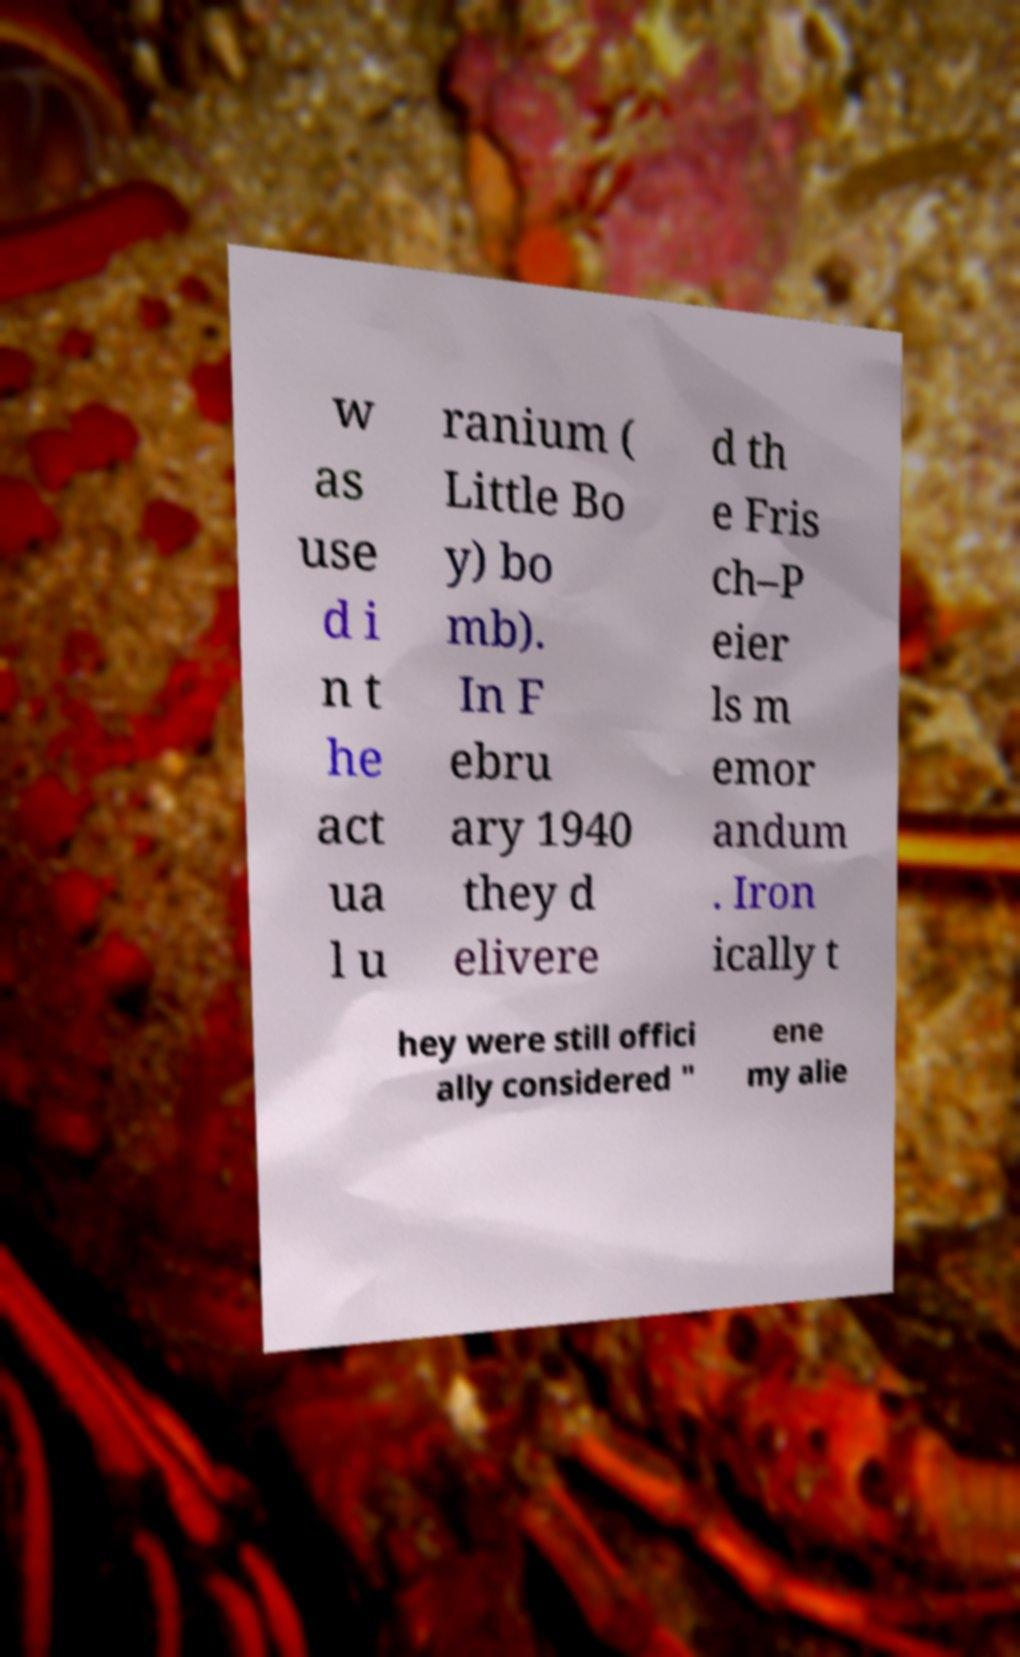I need the written content from this picture converted into text. Can you do that? w as use d i n t he act ua l u ranium ( Little Bo y) bo mb). In F ebru ary 1940 they d elivere d th e Fris ch–P eier ls m emor andum . Iron ically t hey were still offici ally considered " ene my alie 